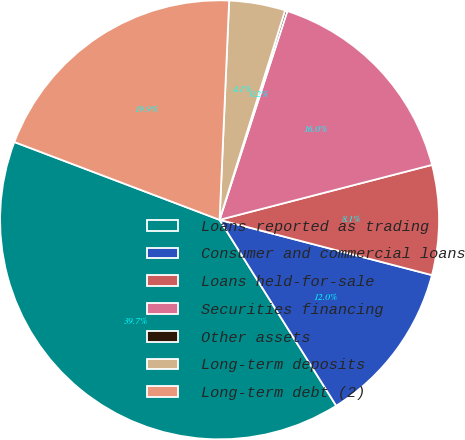<chart> <loc_0><loc_0><loc_500><loc_500><pie_chart><fcel>Loans reported as trading<fcel>Consumer and commercial loans<fcel>Loans held-for-sale<fcel>Securities financing<fcel>Other assets<fcel>Long-term deposits<fcel>Long-term debt (2)<nl><fcel>39.69%<fcel>12.03%<fcel>8.08%<fcel>15.98%<fcel>0.17%<fcel>4.13%<fcel>19.93%<nl></chart> 